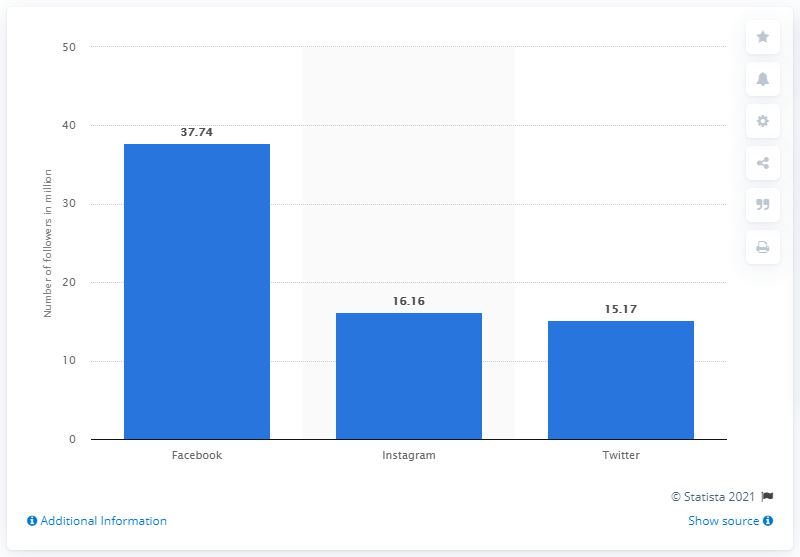Identify some key points in this picture. In November 2019, Arsenal had 37,740 Facebook fans. 